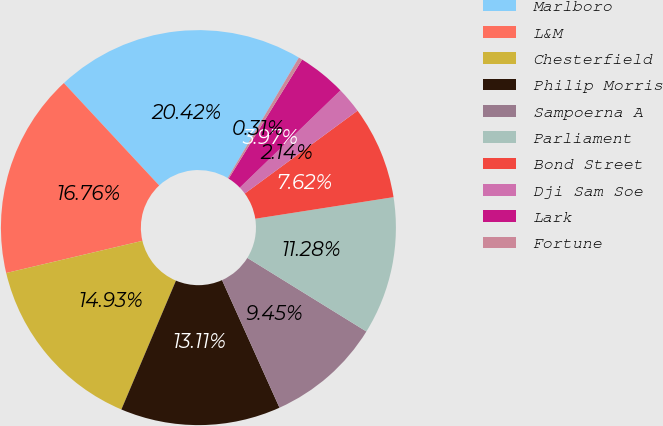Convert chart. <chart><loc_0><loc_0><loc_500><loc_500><pie_chart><fcel>Marlboro<fcel>L&M<fcel>Chesterfield<fcel>Philip Morris<fcel>Sampoerna A<fcel>Parliament<fcel>Bond Street<fcel>Dji Sam Soe<fcel>Lark<fcel>Fortune<nl><fcel>20.42%<fcel>16.76%<fcel>14.93%<fcel>13.11%<fcel>9.45%<fcel>11.28%<fcel>7.62%<fcel>2.14%<fcel>3.97%<fcel>0.31%<nl></chart> 